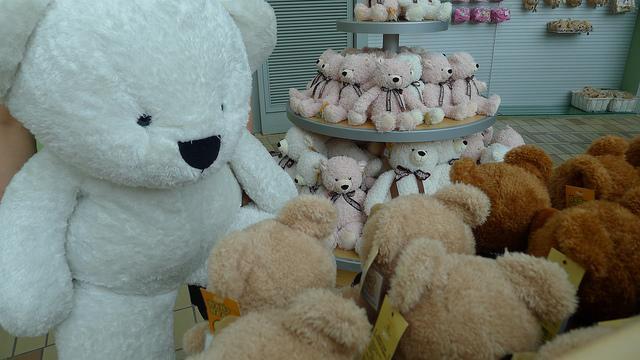How many teddy bears can be seen?
Give a very brief answer. 9. How many legs does the giraffe have?
Give a very brief answer. 0. 